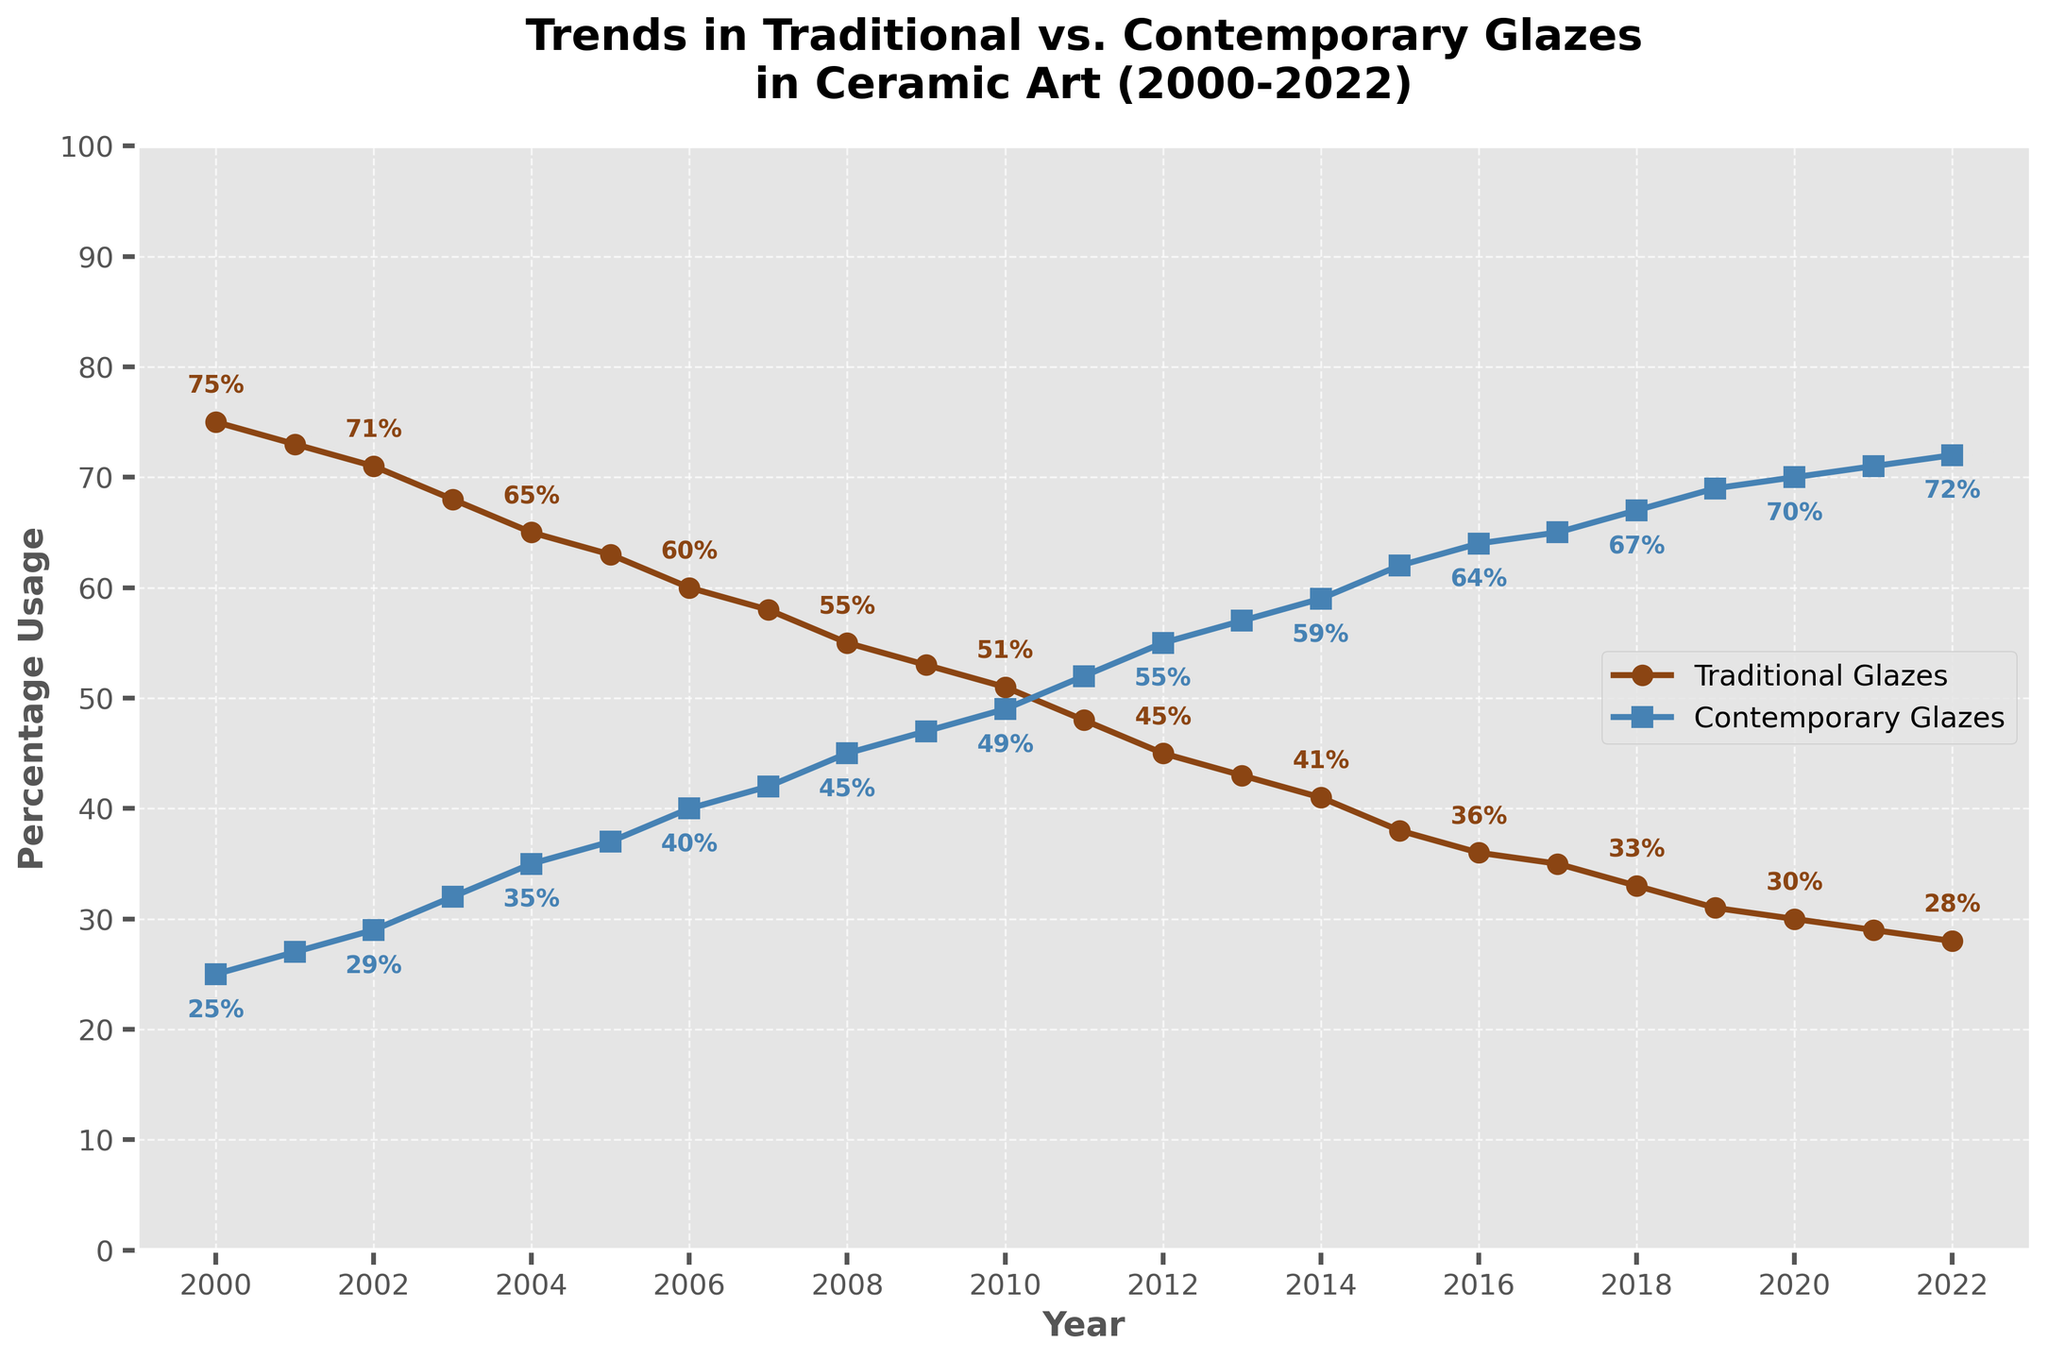Which year had the highest percentage of traditional glaze usage? From the graph, the highest percentage of traditional glaze usage is at the beginning of the time series. By identifying the peak point, which is in the year 2000 with a value of 75%.
Answer: 2000 How has the trend in contemporary glaze usage changed from 2000 to 2022? By tracing the line representing contemporary glazes from 2000 to 2022, it's evident that the percentage steadily increased from 25% to 72%.
Answer: It has increased In what year did contemporary glaze usage surpass traditional glaze usage? By locating the point where the two lines intersect, which indicates when contemporary glazes surpassed traditional glazes, it occurred around 2011 when contemporary glazes reached 52% and traditional glazes dropped to 48%.
Answer: 2011 What is the percentage difference between traditional and contemporary glaze usage in 2015? In 2015, the traditional glaze usage is 38%, and contemporary glaze usage is 62%. The difference is calculated as 62% - 38% = 24%.
Answer: 24% On average, what was the annual decrease in traditional glaze usage from 2000 to 2022? Calculate the total decrease over the period, which is 75% - 28% = 47%, and divide that by the number of years (2022 - 2000 = 22 years). The average annual decrease is 47% / 22 ≈ 2.14%.
Answer: About 2.14% Which year saw the most significant decline in traditional glaze usage? By examining the points and slopes of the traditional glazes line, the steepest decline appears between 2003 and 2004 (68% to 65%), a decline of 3%.
Answer: 2003 to 2004 What is the percentage of contemporary glaze usage in 2019? The value can be directly read from the graph for the year 2019, which is marked at 69%.
Answer: 69% Compare the slope of the lines for traditional and contemporary glazes between 2010 and 2012. From 2010 to 2012: Traditional glazes decreased from 51% to 45%, a decline of 6%. Contemporary glazes increased from 49% to 55%, a rise of 6%. Both slopes have an absolute value of 3% per year but in opposite directions.
Answer: Both had a slope of ±6% over two years Which had a greater percentage change from 2018 to 2020, traditional or contemporary glazes? Traditional glazes changed from 33% to 30%, a change of -3 percentage points. Contemporary glazes changed from 67% to 70%, an increase of 3 percentage points. Therefore, the magnitude of change is equal for both.
Answer: Both had equal changes 